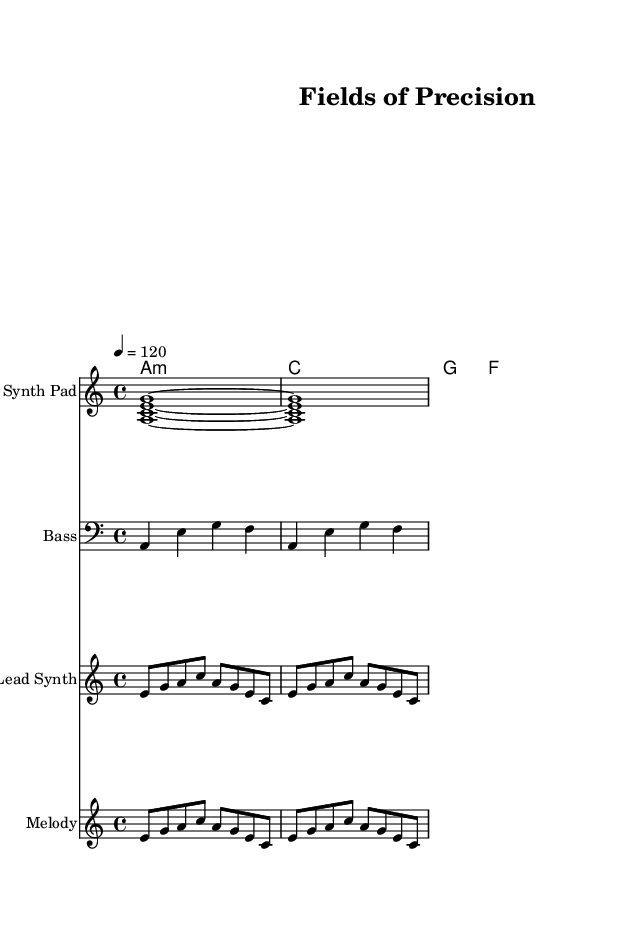What is the key signature of this music? The key signature is indicated by the presence of one flat, which corresponds to the A minor scale. A minor has no sharps and one flat, clearly shown in the sheet music.
Answer: A minor What is the time signature of this music? The time signature is indicated at the beginning; it displays 4/4, which means there are four beats in each measure and the quarter note gets one beat.
Answer: 4/4 What is the tempo marking given in the music? The tempo marking is specified as 4 = 120, which indicates a metronome marking of 120 beats per minute, meaning there are 120 quarter note beats in a minute.
Answer: 120 How many measures are present in the first staff labeled "Synth Pad"? There are two measures shown for the Synth Pad part, which can be counted by dividing the notation into separate segments across the staves.
Answer: 2 What is the harmonic progression used in this piece? The harmonies follow a specific chord progression of A minor, C major, G major, and F major, which are represented in chord symbols throughout the score.
Answer: A minor, C major, G major, F major What instrument is featured in the "Lead Synth" staff? The instrument name is indicated at the beginning of the staff, showing it is assigned to "Lead Synth". This identifies the sound texture of the part played.
Answer: Lead Synth What kind of rhythmic pattern is used in the "Melody" staff? The melody consists of eighth notes that repeat, creating a flowing and rhythmic pattern that complements the ambient feel of the track. The repeated notation denotes this structure.
Answer: Eighth notes 